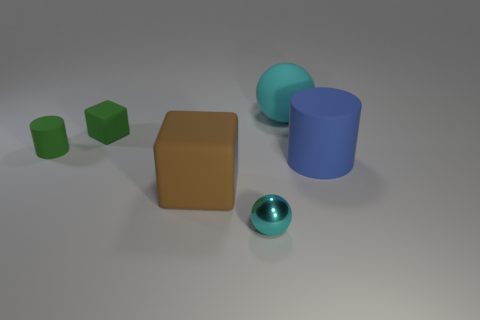Add 4 tiny purple shiny spheres. How many objects exist? 10 Subtract all blocks. How many objects are left? 4 Add 5 large shiny cylinders. How many large shiny cylinders exist? 5 Subtract 0 blue balls. How many objects are left? 6 Subtract all small cyan shiny objects. Subtract all large blocks. How many objects are left? 4 Add 6 small green things. How many small green things are left? 8 